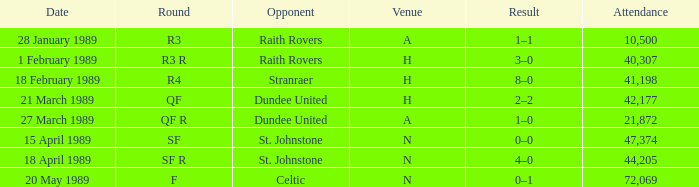On which date does the quarterfinal round happen? 21 March 1989. 